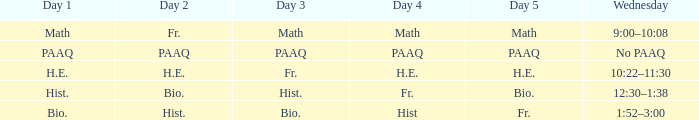What is the Wednesday when day 3 is math? 9:00–10:08. 